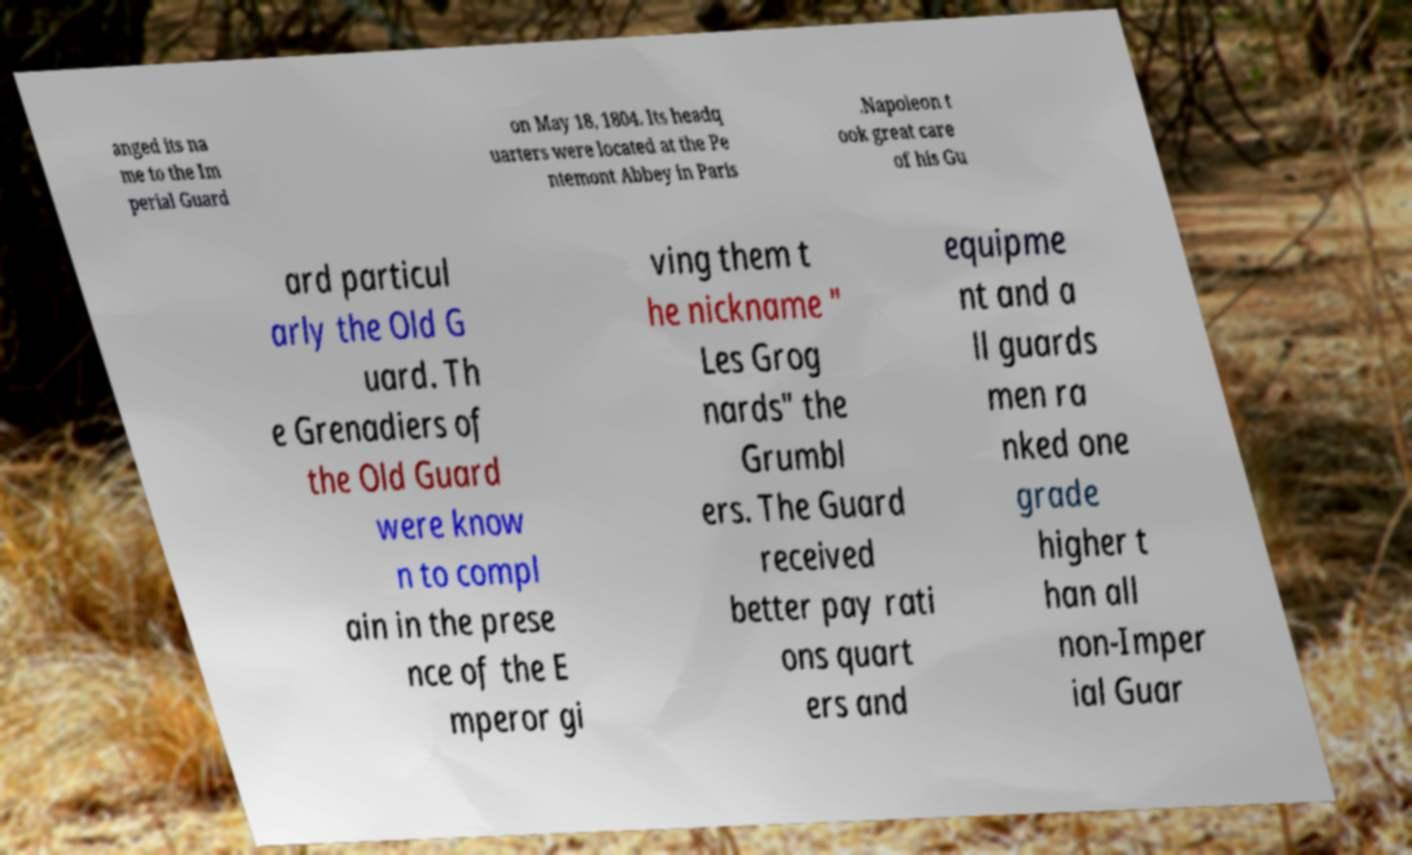Can you accurately transcribe the text from the provided image for me? anged its na me to the Im perial Guard on May 18, 1804. Its headq uarters were located at the Pe ntemont Abbey in Paris .Napoleon t ook great care of his Gu ard particul arly the Old G uard. Th e Grenadiers of the Old Guard were know n to compl ain in the prese nce of the E mperor gi ving them t he nickname " Les Grog nards" the Grumbl ers. The Guard received better pay rati ons quart ers and equipme nt and a ll guards men ra nked one grade higher t han all non-Imper ial Guar 